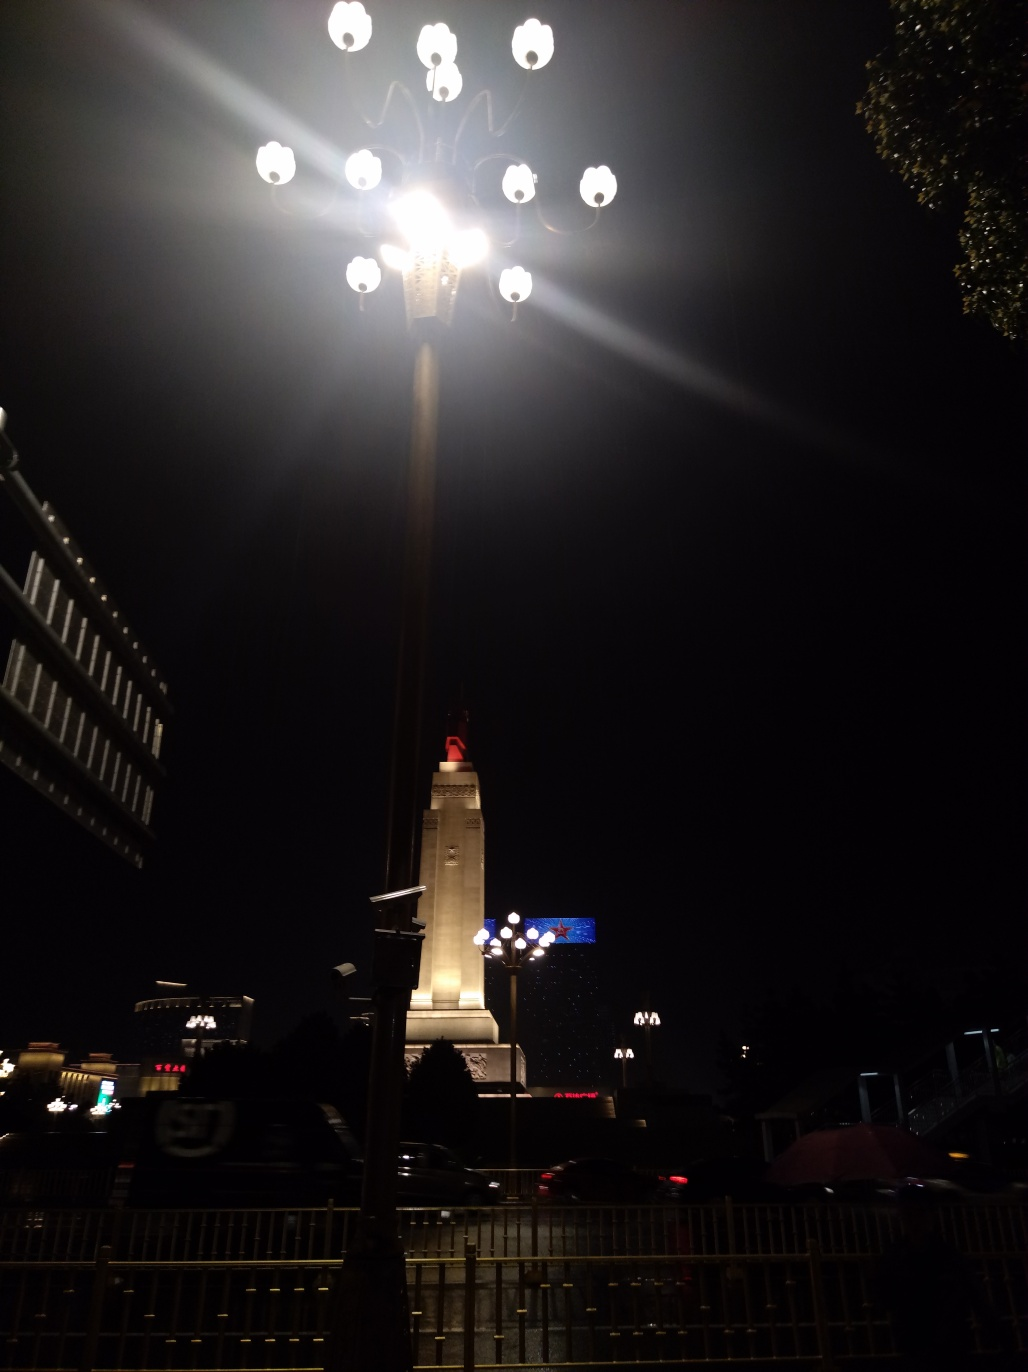What time of day does this photo appear to have been taken? The photo appears to have been taken at nighttime. This is indicated by the dark sky, the illuminated streetlights, and artificial lights from the buildings and lamp post. 